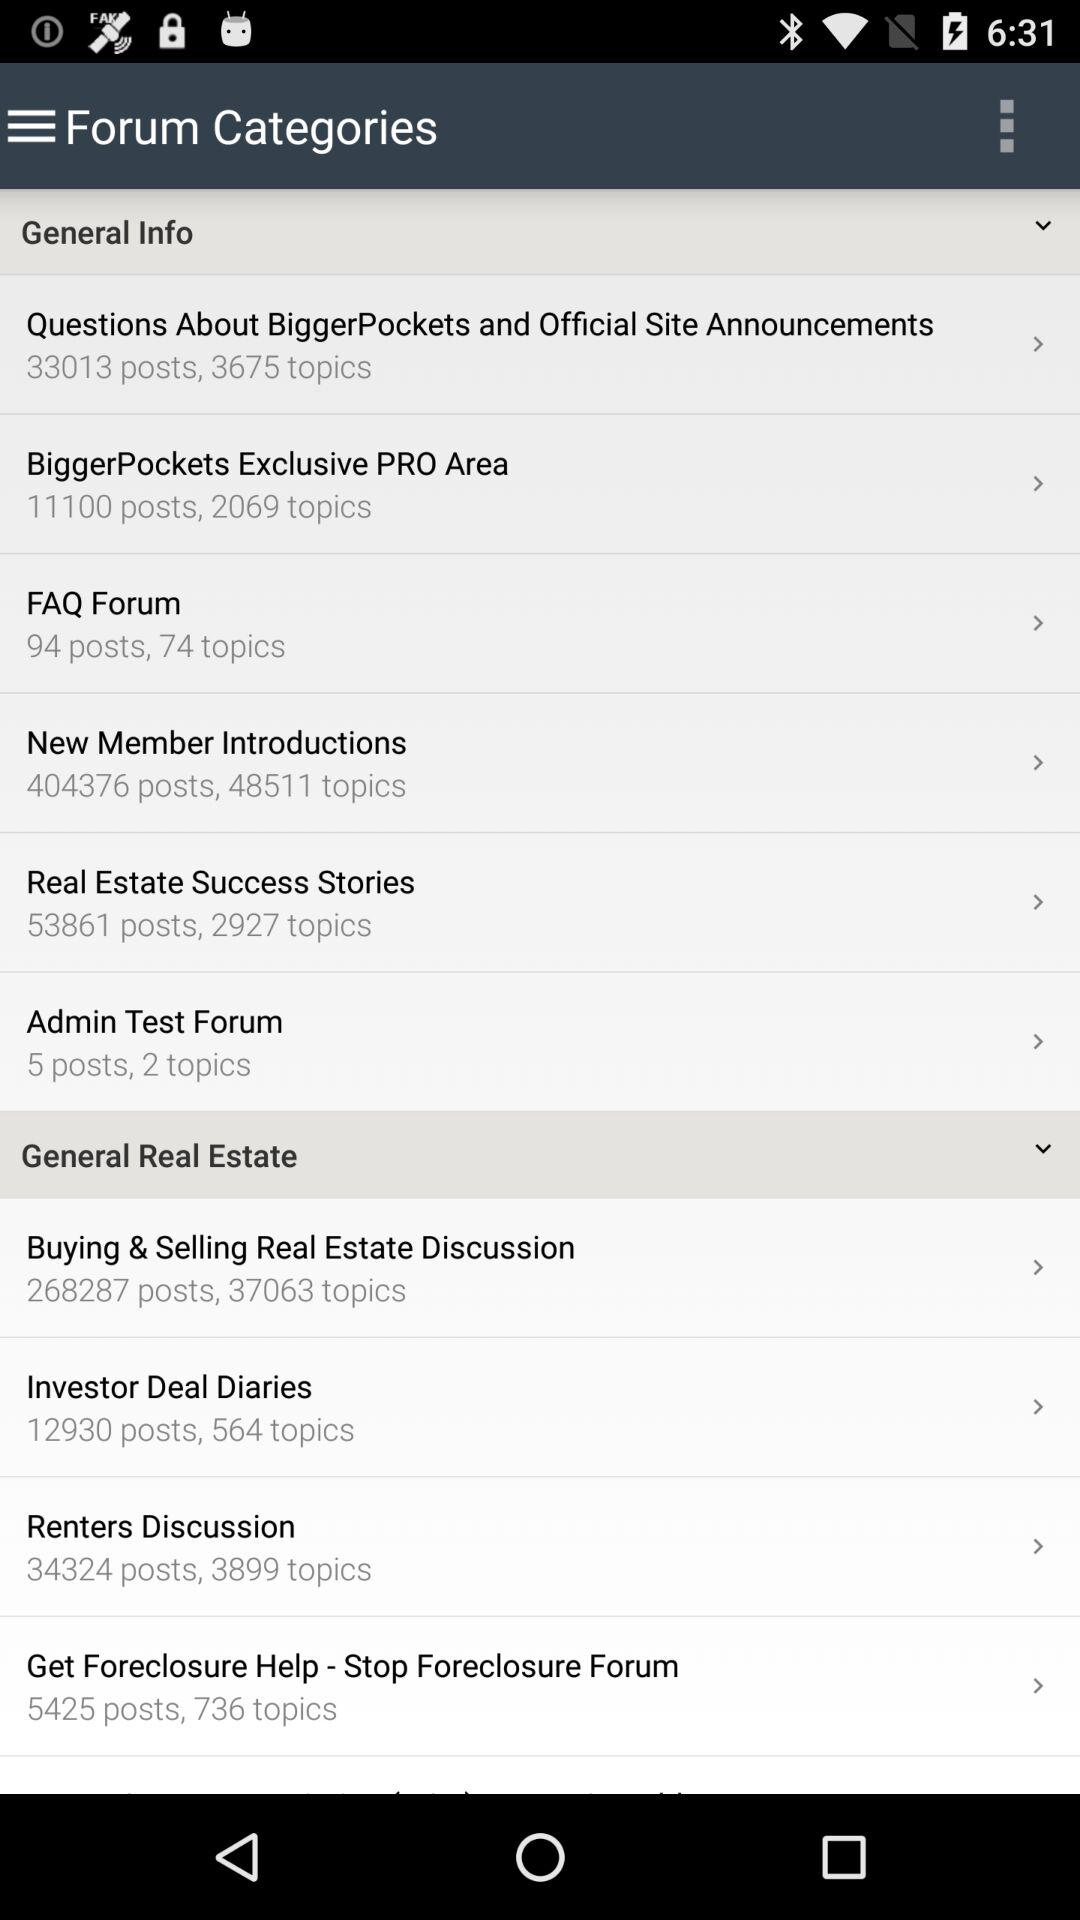What is the total number of topics in the "Admin Test Forum"? The total number of topics in the "Admin Test Forum" is 2. 